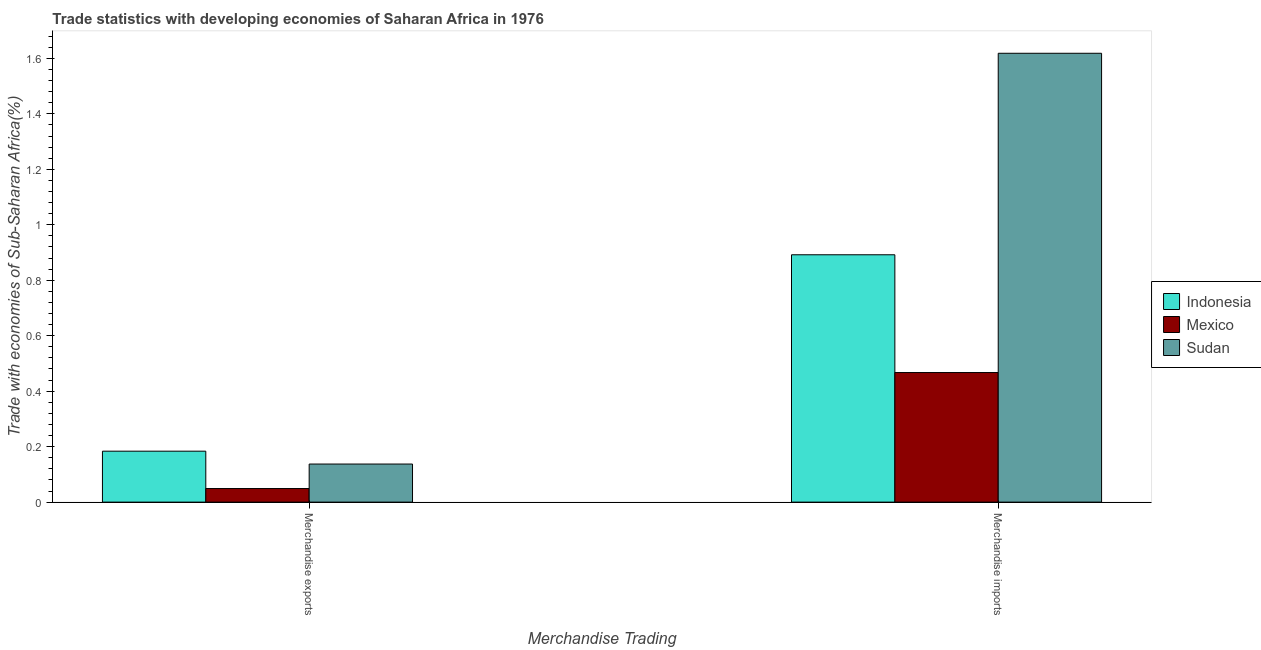Are the number of bars on each tick of the X-axis equal?
Keep it short and to the point. Yes. How many bars are there on the 2nd tick from the right?
Offer a very short reply. 3. What is the label of the 2nd group of bars from the left?
Your answer should be compact. Merchandise imports. What is the merchandise exports in Indonesia?
Keep it short and to the point. 0.18. Across all countries, what is the maximum merchandise exports?
Provide a succinct answer. 0.18. Across all countries, what is the minimum merchandise imports?
Your answer should be very brief. 0.47. In which country was the merchandise imports minimum?
Give a very brief answer. Mexico. What is the total merchandise imports in the graph?
Provide a succinct answer. 2.98. What is the difference between the merchandise imports in Mexico and that in Sudan?
Give a very brief answer. -1.15. What is the difference between the merchandise exports in Indonesia and the merchandise imports in Mexico?
Give a very brief answer. -0.28. What is the average merchandise imports per country?
Provide a short and direct response. 0.99. What is the difference between the merchandise imports and merchandise exports in Indonesia?
Give a very brief answer. 0.71. In how many countries, is the merchandise exports greater than 0.16 %?
Provide a short and direct response. 1. What is the ratio of the merchandise exports in Sudan to that in Mexico?
Give a very brief answer. 2.8. What does the 1st bar from the left in Merchandise exports represents?
Your answer should be very brief. Indonesia. Are all the bars in the graph horizontal?
Your answer should be compact. No. What is the difference between two consecutive major ticks on the Y-axis?
Your answer should be very brief. 0.2. Are the values on the major ticks of Y-axis written in scientific E-notation?
Ensure brevity in your answer.  No. Where does the legend appear in the graph?
Provide a succinct answer. Center right. What is the title of the graph?
Offer a very short reply. Trade statistics with developing economies of Saharan Africa in 1976. Does "Andorra" appear as one of the legend labels in the graph?
Your response must be concise. No. What is the label or title of the X-axis?
Make the answer very short. Merchandise Trading. What is the label or title of the Y-axis?
Ensure brevity in your answer.  Trade with economies of Sub-Saharan Africa(%). What is the Trade with economies of Sub-Saharan Africa(%) of Indonesia in Merchandise exports?
Offer a very short reply. 0.18. What is the Trade with economies of Sub-Saharan Africa(%) in Mexico in Merchandise exports?
Offer a terse response. 0.05. What is the Trade with economies of Sub-Saharan Africa(%) of Sudan in Merchandise exports?
Give a very brief answer. 0.14. What is the Trade with economies of Sub-Saharan Africa(%) in Indonesia in Merchandise imports?
Your response must be concise. 0.89. What is the Trade with economies of Sub-Saharan Africa(%) in Mexico in Merchandise imports?
Provide a succinct answer. 0.47. What is the Trade with economies of Sub-Saharan Africa(%) of Sudan in Merchandise imports?
Give a very brief answer. 1.62. Across all Merchandise Trading, what is the maximum Trade with economies of Sub-Saharan Africa(%) of Indonesia?
Provide a succinct answer. 0.89. Across all Merchandise Trading, what is the maximum Trade with economies of Sub-Saharan Africa(%) in Mexico?
Provide a short and direct response. 0.47. Across all Merchandise Trading, what is the maximum Trade with economies of Sub-Saharan Africa(%) of Sudan?
Offer a terse response. 1.62. Across all Merchandise Trading, what is the minimum Trade with economies of Sub-Saharan Africa(%) of Indonesia?
Provide a short and direct response. 0.18. Across all Merchandise Trading, what is the minimum Trade with economies of Sub-Saharan Africa(%) in Mexico?
Provide a short and direct response. 0.05. Across all Merchandise Trading, what is the minimum Trade with economies of Sub-Saharan Africa(%) in Sudan?
Provide a succinct answer. 0.14. What is the total Trade with economies of Sub-Saharan Africa(%) in Indonesia in the graph?
Keep it short and to the point. 1.08. What is the total Trade with economies of Sub-Saharan Africa(%) of Mexico in the graph?
Ensure brevity in your answer.  0.52. What is the total Trade with economies of Sub-Saharan Africa(%) in Sudan in the graph?
Ensure brevity in your answer.  1.76. What is the difference between the Trade with economies of Sub-Saharan Africa(%) of Indonesia in Merchandise exports and that in Merchandise imports?
Ensure brevity in your answer.  -0.71. What is the difference between the Trade with economies of Sub-Saharan Africa(%) of Mexico in Merchandise exports and that in Merchandise imports?
Provide a succinct answer. -0.42. What is the difference between the Trade with economies of Sub-Saharan Africa(%) of Sudan in Merchandise exports and that in Merchandise imports?
Your answer should be compact. -1.48. What is the difference between the Trade with economies of Sub-Saharan Africa(%) of Indonesia in Merchandise exports and the Trade with economies of Sub-Saharan Africa(%) of Mexico in Merchandise imports?
Your answer should be compact. -0.28. What is the difference between the Trade with economies of Sub-Saharan Africa(%) in Indonesia in Merchandise exports and the Trade with economies of Sub-Saharan Africa(%) in Sudan in Merchandise imports?
Offer a terse response. -1.43. What is the difference between the Trade with economies of Sub-Saharan Africa(%) of Mexico in Merchandise exports and the Trade with economies of Sub-Saharan Africa(%) of Sudan in Merchandise imports?
Provide a short and direct response. -1.57. What is the average Trade with economies of Sub-Saharan Africa(%) in Indonesia per Merchandise Trading?
Your response must be concise. 0.54. What is the average Trade with economies of Sub-Saharan Africa(%) in Mexico per Merchandise Trading?
Give a very brief answer. 0.26. What is the average Trade with economies of Sub-Saharan Africa(%) of Sudan per Merchandise Trading?
Your answer should be compact. 0.88. What is the difference between the Trade with economies of Sub-Saharan Africa(%) of Indonesia and Trade with economies of Sub-Saharan Africa(%) of Mexico in Merchandise exports?
Offer a terse response. 0.13. What is the difference between the Trade with economies of Sub-Saharan Africa(%) in Indonesia and Trade with economies of Sub-Saharan Africa(%) in Sudan in Merchandise exports?
Your response must be concise. 0.05. What is the difference between the Trade with economies of Sub-Saharan Africa(%) in Mexico and Trade with economies of Sub-Saharan Africa(%) in Sudan in Merchandise exports?
Provide a short and direct response. -0.09. What is the difference between the Trade with economies of Sub-Saharan Africa(%) in Indonesia and Trade with economies of Sub-Saharan Africa(%) in Mexico in Merchandise imports?
Your response must be concise. 0.42. What is the difference between the Trade with economies of Sub-Saharan Africa(%) of Indonesia and Trade with economies of Sub-Saharan Africa(%) of Sudan in Merchandise imports?
Your response must be concise. -0.73. What is the difference between the Trade with economies of Sub-Saharan Africa(%) in Mexico and Trade with economies of Sub-Saharan Africa(%) in Sudan in Merchandise imports?
Offer a terse response. -1.15. What is the ratio of the Trade with economies of Sub-Saharan Africa(%) in Indonesia in Merchandise exports to that in Merchandise imports?
Offer a very short reply. 0.21. What is the ratio of the Trade with economies of Sub-Saharan Africa(%) of Mexico in Merchandise exports to that in Merchandise imports?
Provide a short and direct response. 0.1. What is the ratio of the Trade with economies of Sub-Saharan Africa(%) of Sudan in Merchandise exports to that in Merchandise imports?
Offer a very short reply. 0.08. What is the difference between the highest and the second highest Trade with economies of Sub-Saharan Africa(%) of Indonesia?
Keep it short and to the point. 0.71. What is the difference between the highest and the second highest Trade with economies of Sub-Saharan Africa(%) of Mexico?
Make the answer very short. 0.42. What is the difference between the highest and the second highest Trade with economies of Sub-Saharan Africa(%) of Sudan?
Your answer should be very brief. 1.48. What is the difference between the highest and the lowest Trade with economies of Sub-Saharan Africa(%) in Indonesia?
Provide a short and direct response. 0.71. What is the difference between the highest and the lowest Trade with economies of Sub-Saharan Africa(%) of Mexico?
Offer a terse response. 0.42. What is the difference between the highest and the lowest Trade with economies of Sub-Saharan Africa(%) of Sudan?
Ensure brevity in your answer.  1.48. 